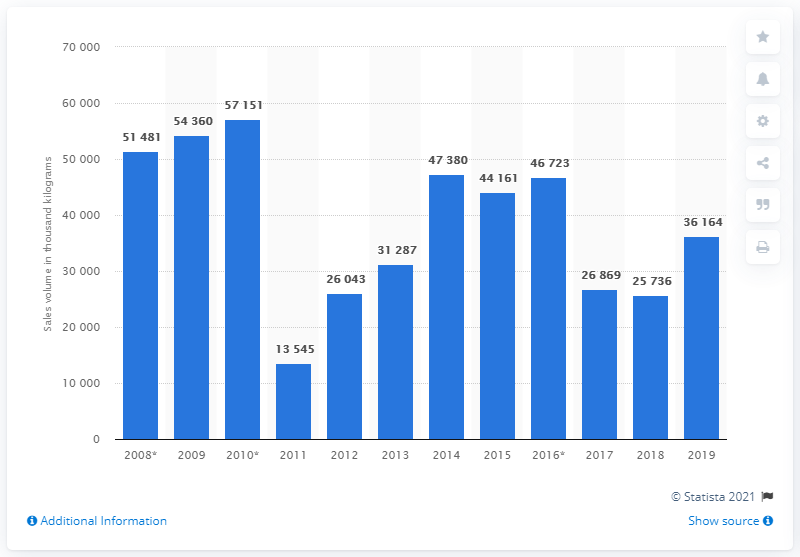Highlight a few significant elements in this photo. The sales volume of citrus marmalades in 2019 was approximately 36,164 units. 